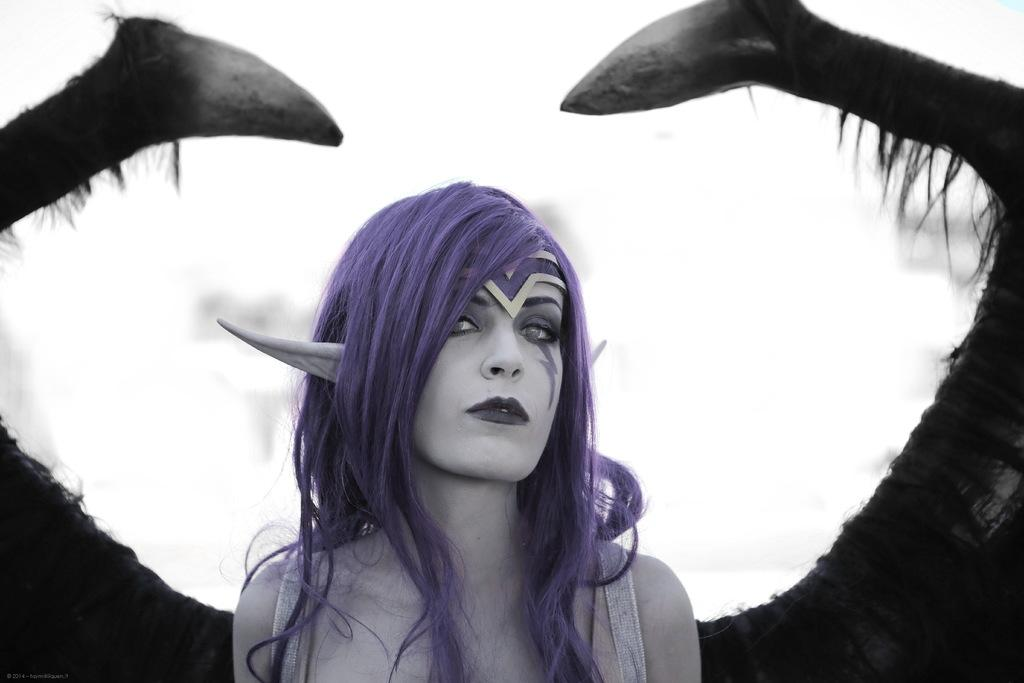What is the main subject of the image? There is a person in the image. Can you describe the person's appearance? The person has blue hair. What might the person be doing in the image? The person appears to be presenting. How many houses can be seen in the image? There are no houses present in the image. What type of wood is the pig using to build the structure in the image? There is no pig or wood present in the image. 